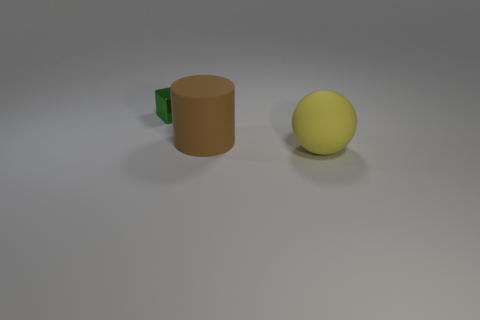There is a matte thing behind the large object right of the large matte thing left of the large sphere; how big is it?
Ensure brevity in your answer.  Large. Are there the same number of yellow things behind the large yellow matte object and cylinders behind the small green shiny object?
Keep it short and to the point. Yes. Are there any big green things made of the same material as the large yellow sphere?
Your answer should be very brief. No. Are the big thing in front of the big cylinder and the large brown cylinder made of the same material?
Ensure brevity in your answer.  Yes. There is a object that is on the right side of the block and to the left of the ball; how big is it?
Give a very brief answer. Large. What is the color of the large sphere?
Your answer should be very brief. Yellow. How many large purple things are there?
Your answer should be very brief. 0. How many metallic blocks are the same color as the tiny object?
Your answer should be compact. 0. There is a thing left of the rubber object that is to the left of the big matte thing that is in front of the brown cylinder; what is its color?
Make the answer very short. Green. What color is the object to the right of the brown thing?
Ensure brevity in your answer.  Yellow. 